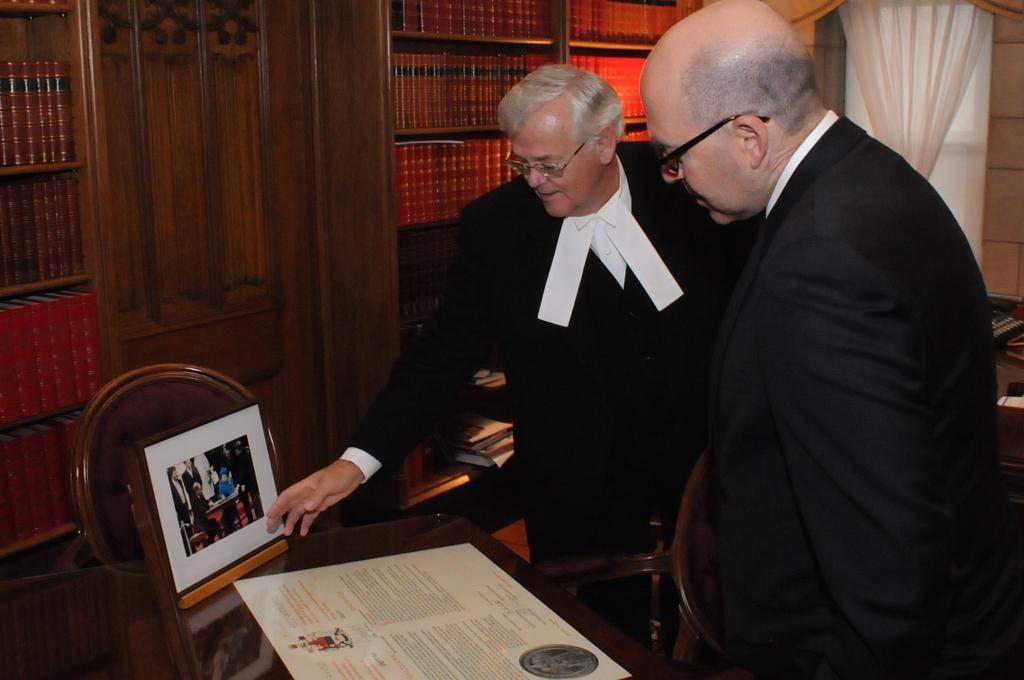Please provide a concise description of this image. In this image I can see two men are standing and wearing black color clothes. Here I can see a table which has a photo and some other object on it. In the background I can see white color curtains, shelves which has books and a chair on the floor. 